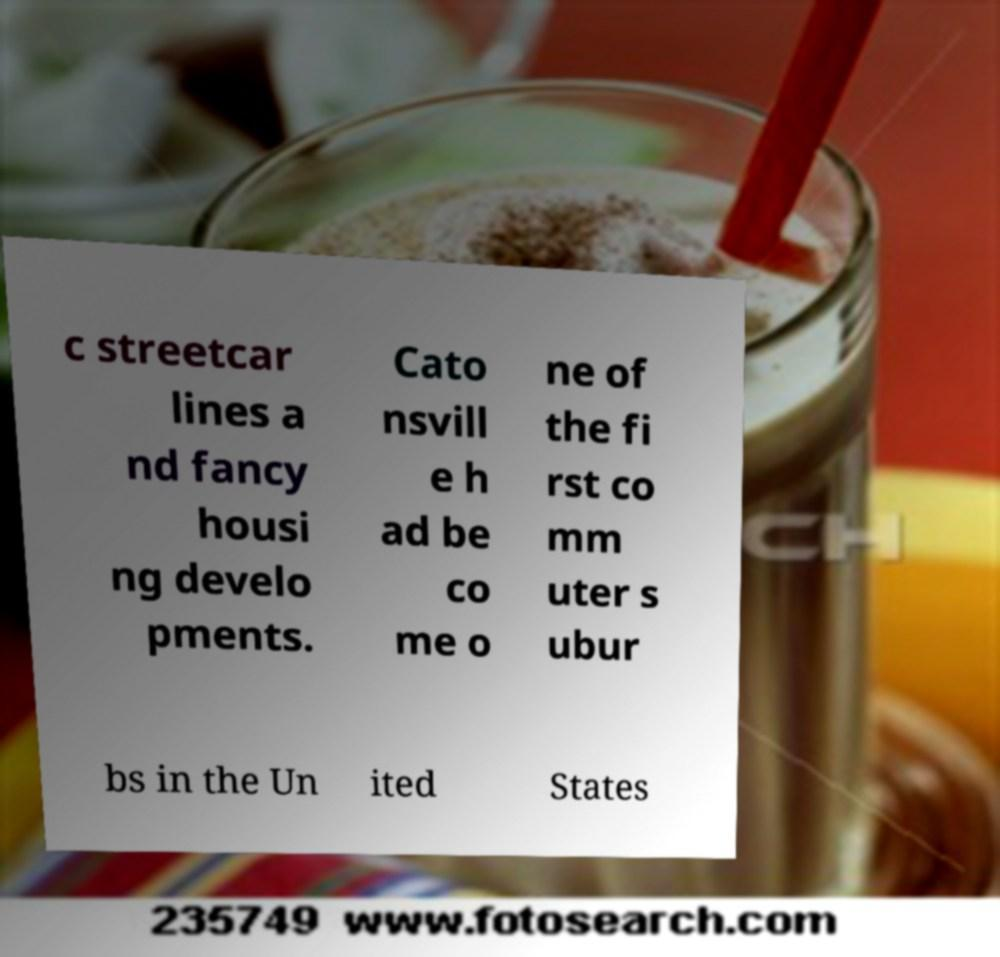Could you assist in decoding the text presented in this image and type it out clearly? c streetcar lines a nd fancy housi ng develo pments. Cato nsvill e h ad be co me o ne of the fi rst co mm uter s ubur bs in the Un ited States 